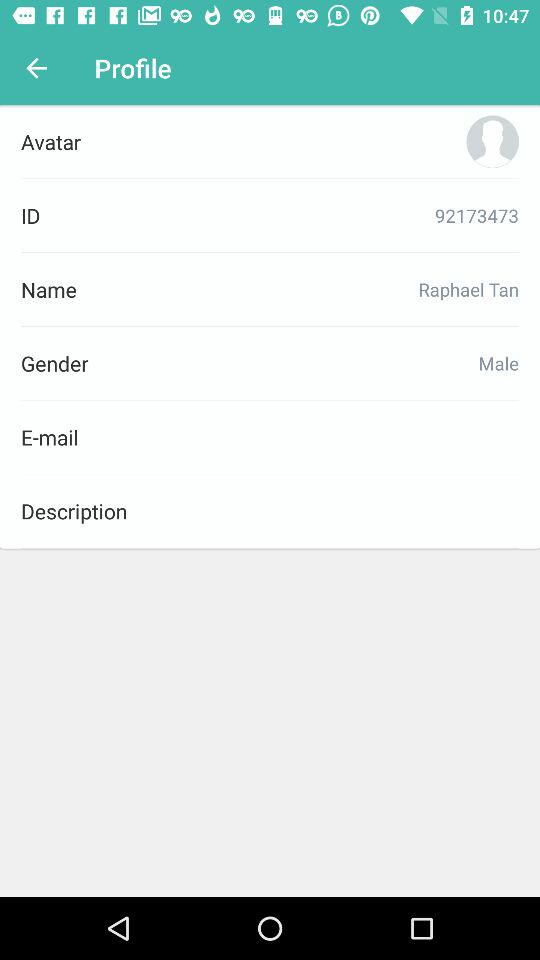What is the ID number? The ID number is 92173473. 